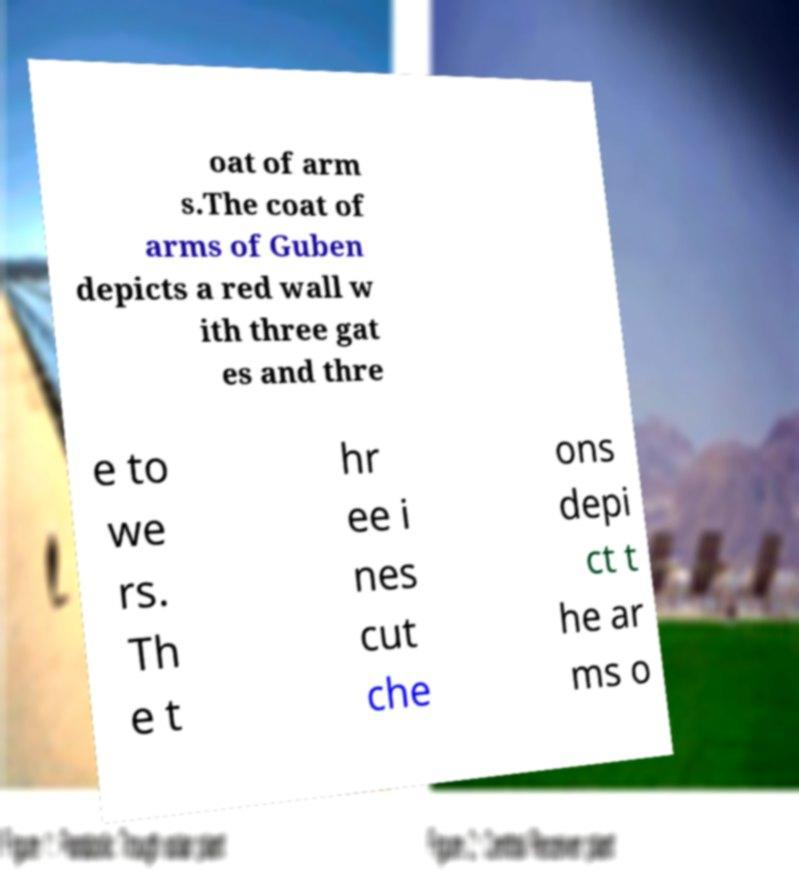Could you extract and type out the text from this image? oat of arm s.The coat of arms of Guben depicts a red wall w ith three gat es and thre e to we rs. Th e t hr ee i nes cut che ons depi ct t he ar ms o 